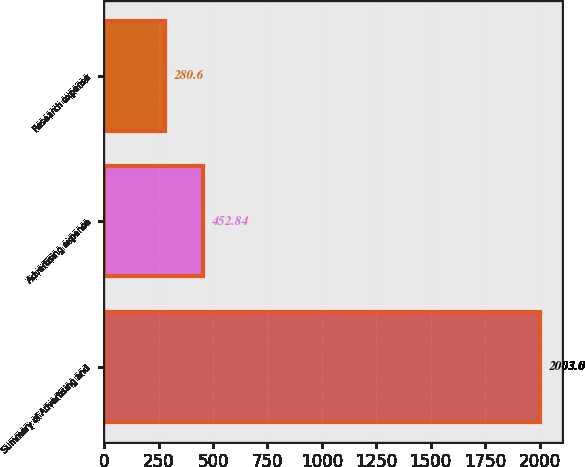Convert chart to OTSL. <chart><loc_0><loc_0><loc_500><loc_500><bar_chart><fcel>Summary of Advertising and<fcel>Advertising expense<fcel>Research expense<nl><fcel>2003<fcel>452.84<fcel>280.6<nl></chart> 